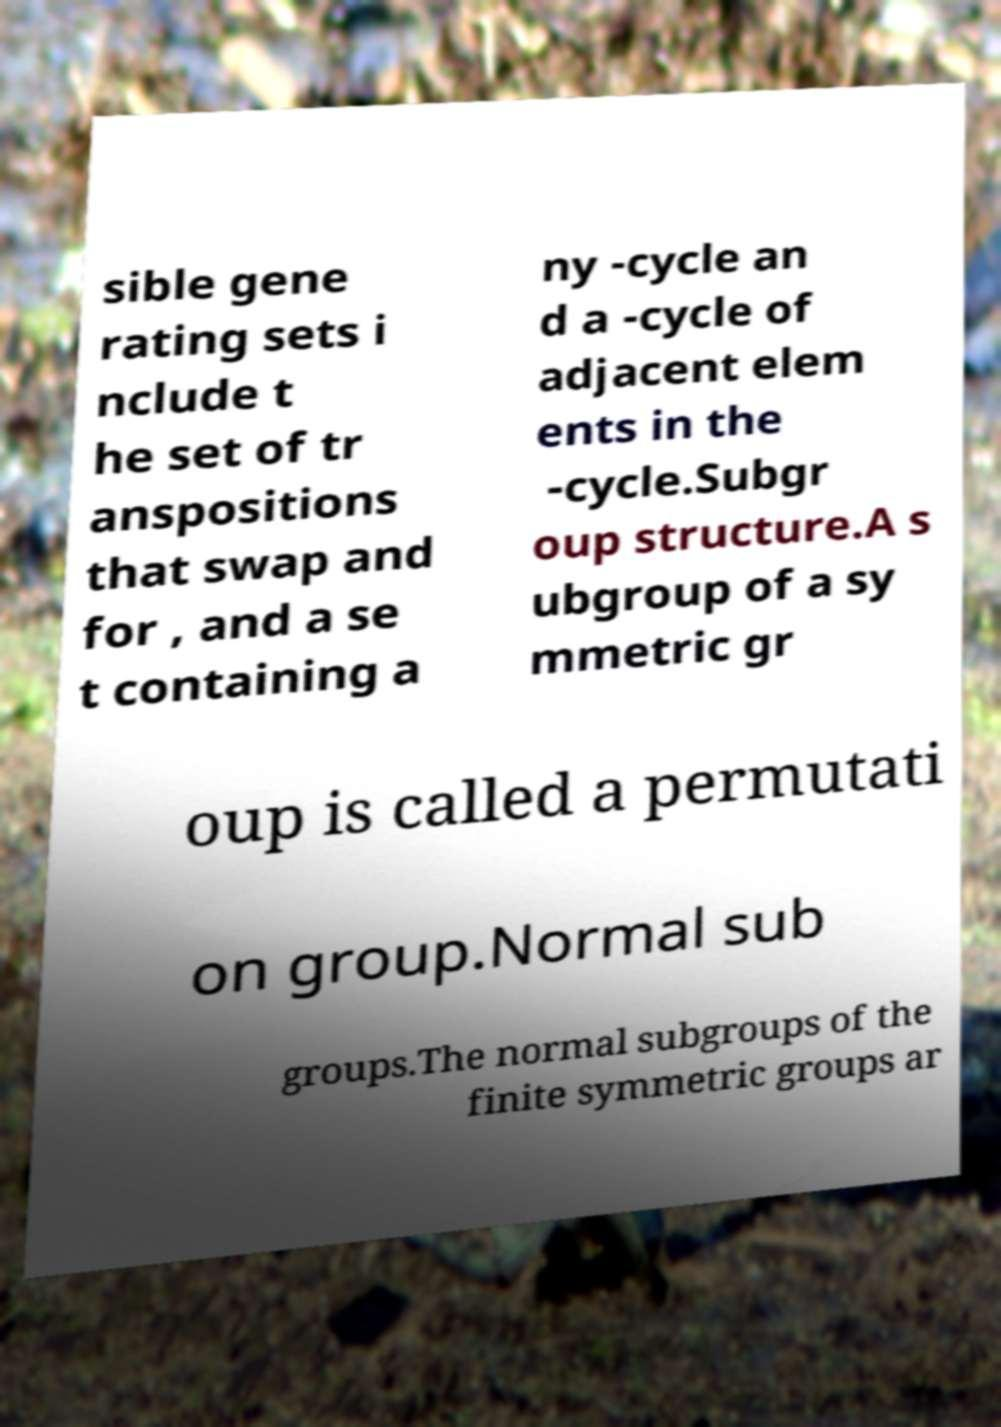Please identify and transcribe the text found in this image. sible gene rating sets i nclude t he set of tr anspositions that swap and for , and a se t containing a ny -cycle an d a -cycle of adjacent elem ents in the -cycle.Subgr oup structure.A s ubgroup of a sy mmetric gr oup is called a permutati on group.Normal sub groups.The normal subgroups of the finite symmetric groups ar 